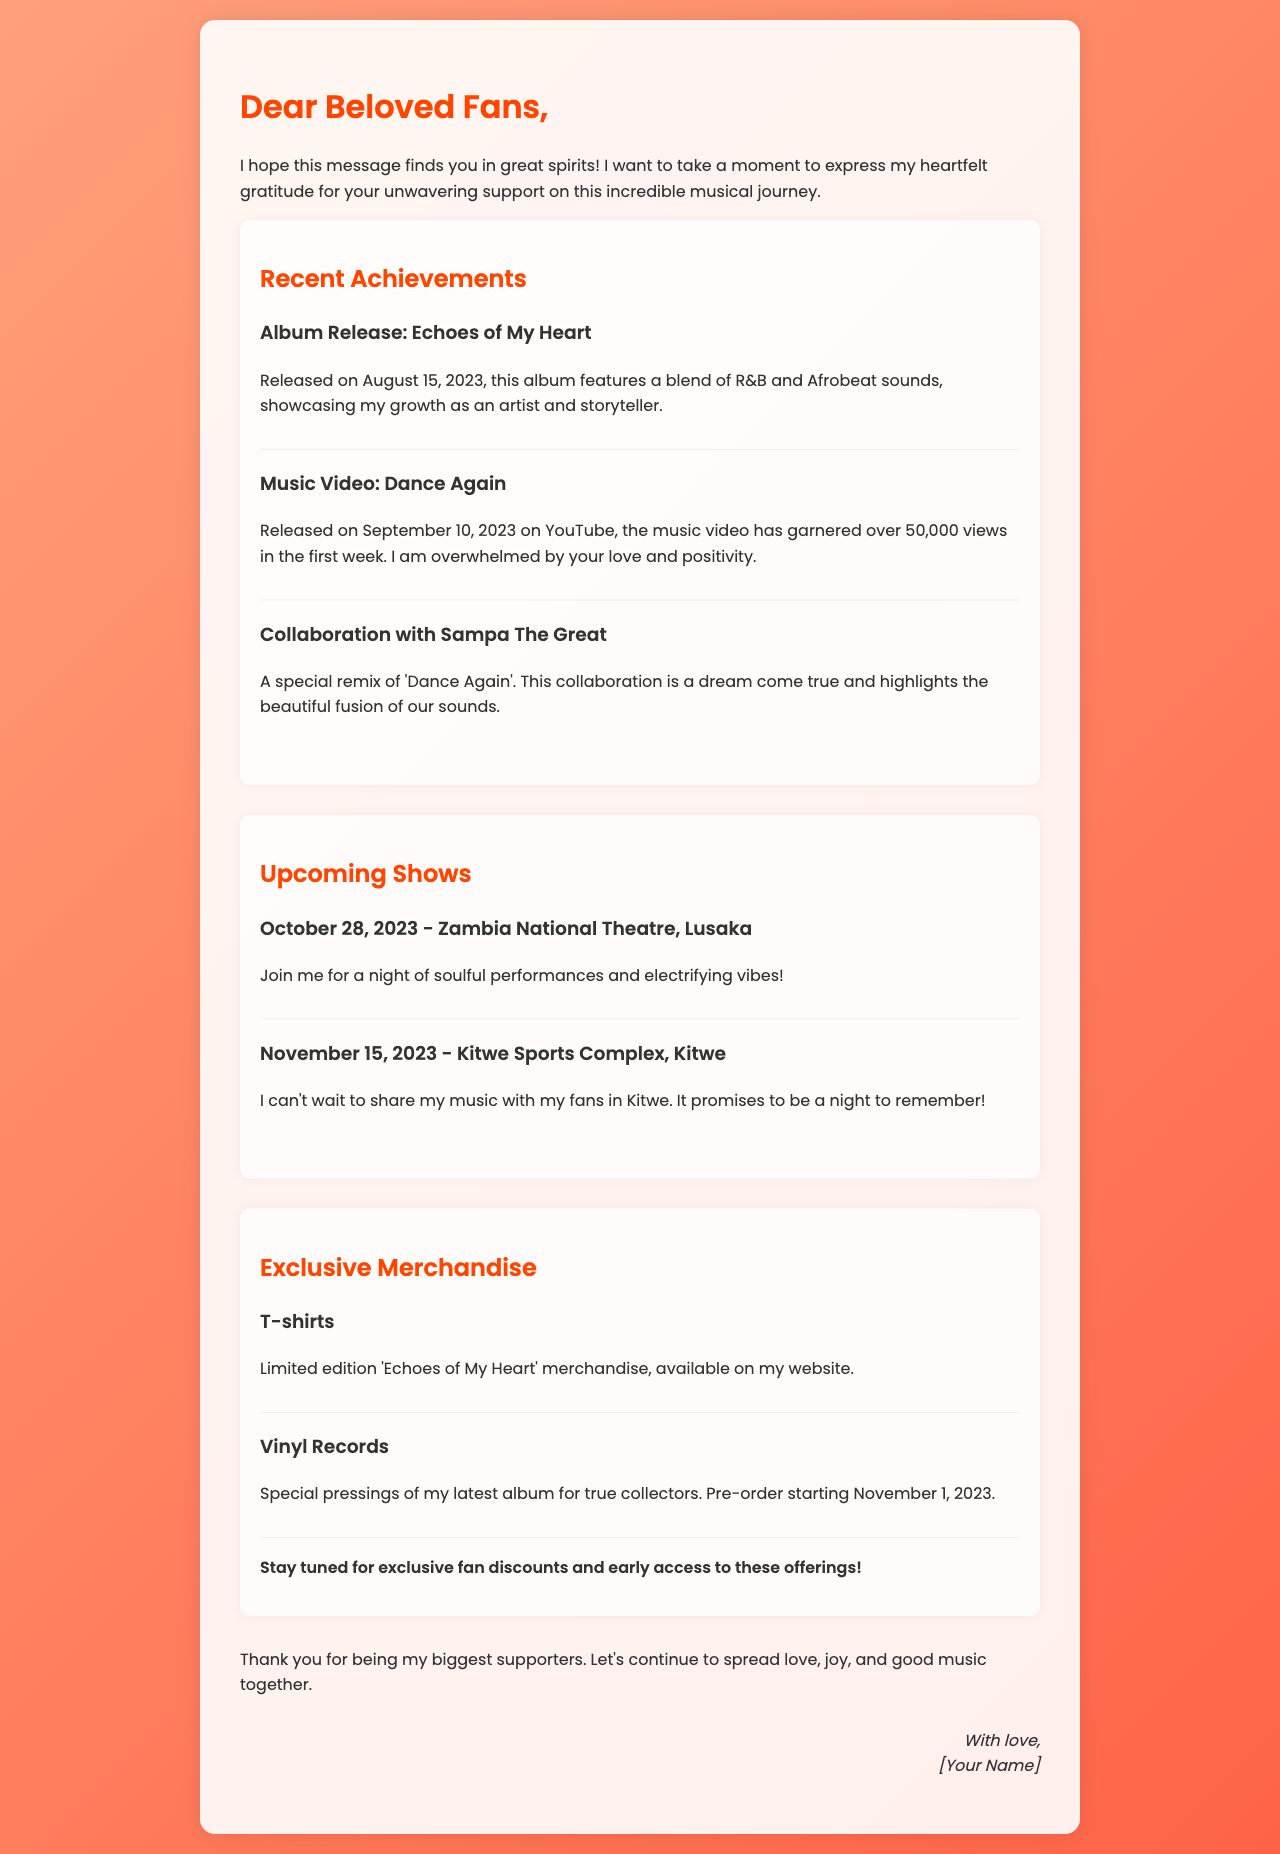What is the title of the latest album? The title of the latest album is mentioned in the section about recent achievements.
Answer: Echoes of My Heart When was the album "Echoes of My Heart" released? The release date is specified in the achievements section of the document.
Answer: August 15, 2023 How many views did the music video for "Dance Again" receive in the first week? The document states the number of views from the achievements section.
Answer: 50,000 Who collaborated on the remix of "Dance Again"? The document specifies the artist who collaborated with the singer in the achievements section.
Answer: Sampa The Great What is the date of the upcoming show in Lusaka? The document mentions the specific date and location of the show.
Answer: October 28, 2023 What type of exclusive merchandise is being offered? The document lists specific types of merchandise in the respective section.
Answer: T-shirts What is the pre-order start date for the vinyl records? The document states the pre-order date in the exclusive merchandise section.
Answer: November 1, 2023 How many upcoming shows are mentioned in the document? The document provides a count of shows listed in the upcoming shows section.
Answer: Two What is the main purpose of the letter? The document indicates that the letter is meant to express gratitude and share updates with fans.
Answer: Thank you letter 